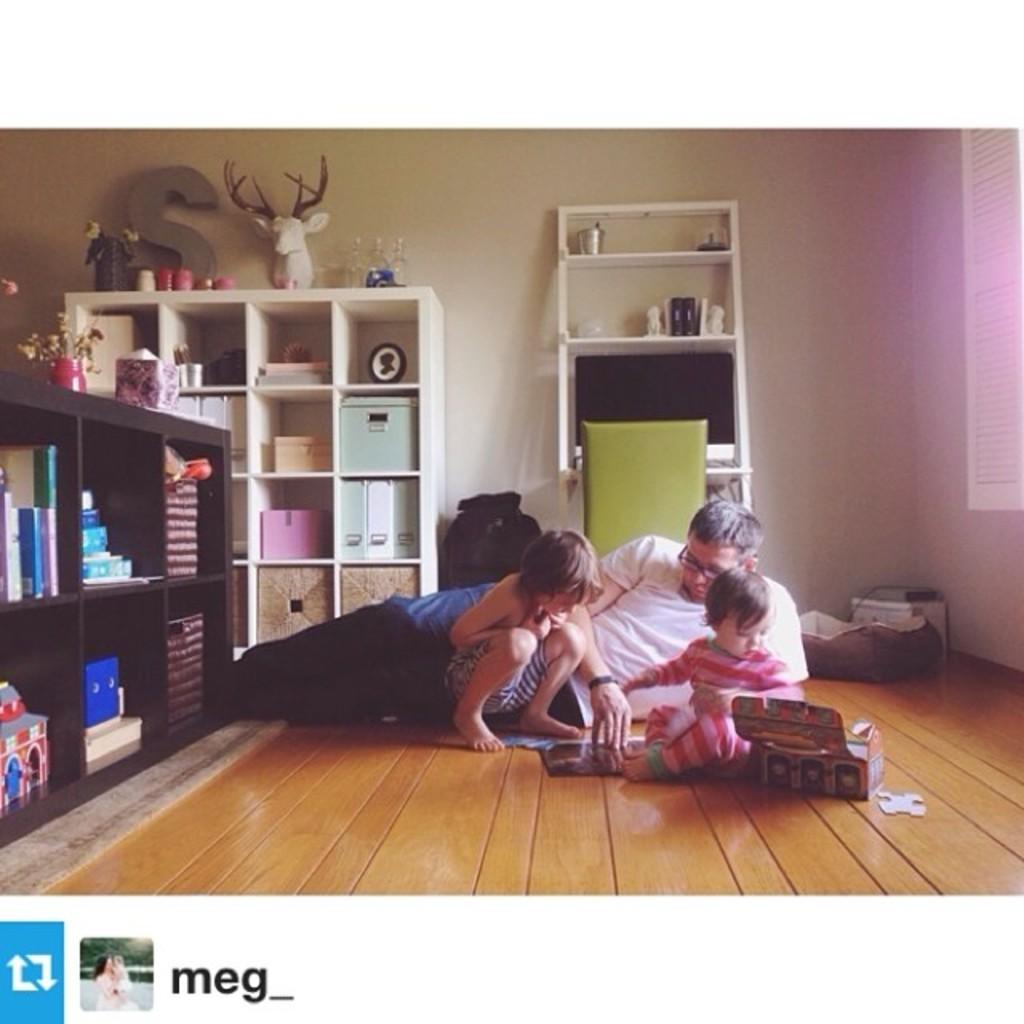Who uploaded this photo?
Your answer should be compact. Meg_. What letter is on the bookshelf?
Provide a short and direct response. S. 